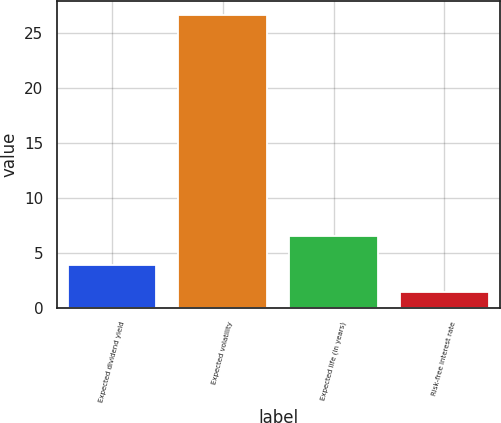Convert chart to OTSL. <chart><loc_0><loc_0><loc_500><loc_500><bar_chart><fcel>Expected dividend yield<fcel>Expected volatility<fcel>Expected life (in years)<fcel>Risk-free interest rate<nl><fcel>3.91<fcel>26.57<fcel>6.5<fcel>1.39<nl></chart> 